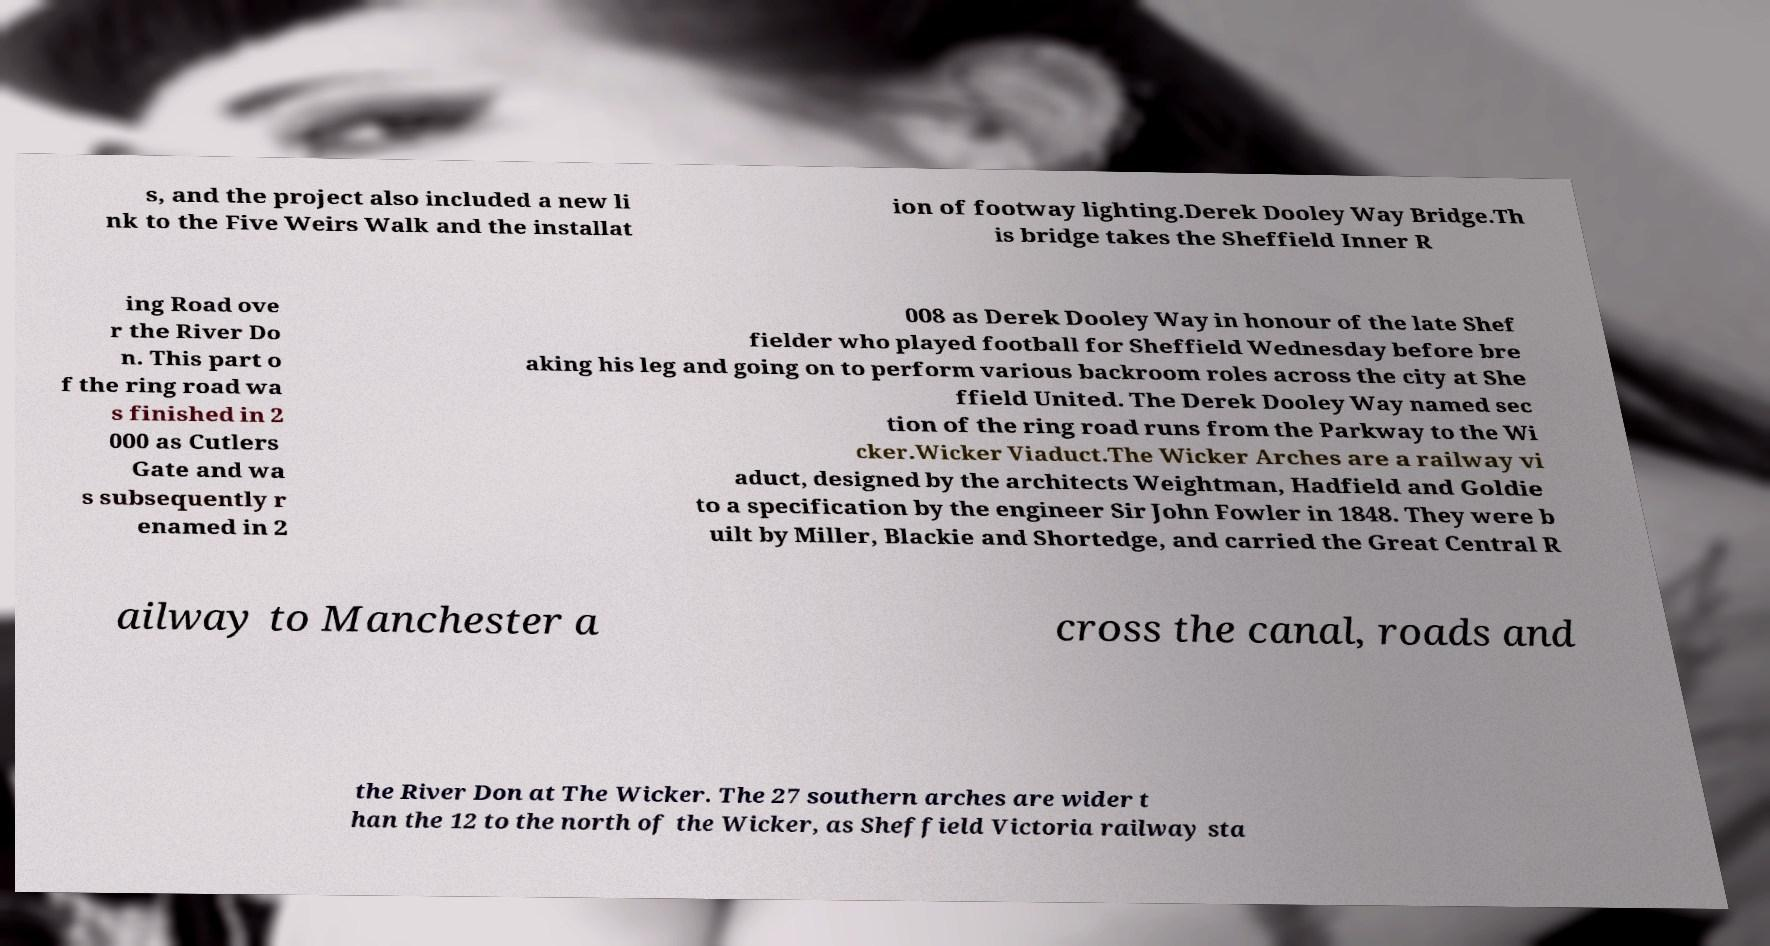Can you read and provide the text displayed in the image?This photo seems to have some interesting text. Can you extract and type it out for me? s, and the project also included a new li nk to the Five Weirs Walk and the installat ion of footway lighting.Derek Dooley Way Bridge.Th is bridge takes the Sheffield Inner R ing Road ove r the River Do n. This part o f the ring road wa s finished in 2 000 as Cutlers Gate and wa s subsequently r enamed in 2 008 as Derek Dooley Way in honour of the late Shef fielder who played football for Sheffield Wednesday before bre aking his leg and going on to perform various backroom roles across the city at She ffield United. The Derek Dooley Way named sec tion of the ring road runs from the Parkway to the Wi cker.Wicker Viaduct.The Wicker Arches are a railway vi aduct, designed by the architects Weightman, Hadfield and Goldie to a specification by the engineer Sir John Fowler in 1848. They were b uilt by Miller, Blackie and Shortedge, and carried the Great Central R ailway to Manchester a cross the canal, roads and the River Don at The Wicker. The 27 southern arches are wider t han the 12 to the north of the Wicker, as Sheffield Victoria railway sta 